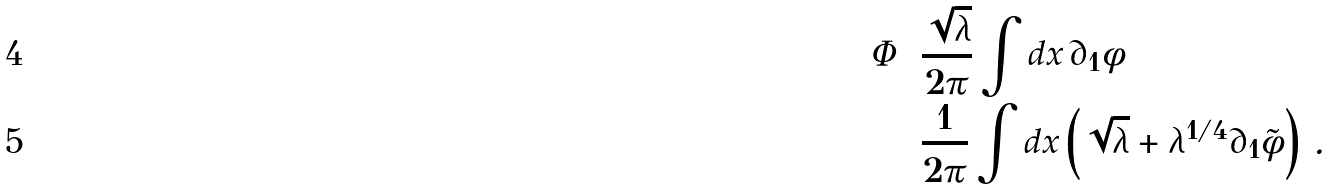Convert formula to latex. <formula><loc_0><loc_0><loc_500><loc_500>\Phi & = \frac { \sqrt { \lambda } } { 2 \pi } \int d x \, \partial _ { 1 } \phi \\ & = \frac { 1 } { 2 \pi } \int d x \left ( \sqrt { \lambda } + \lambda ^ { 1 / 4 } \partial _ { 1 } \tilde { \phi } \right ) \, .</formula> 